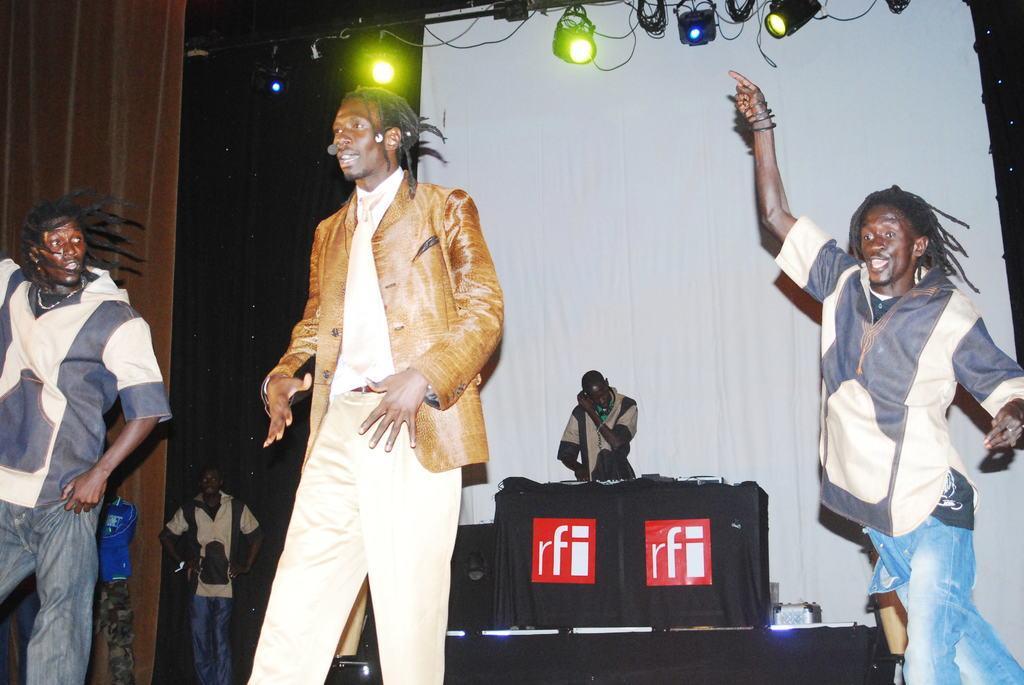How would you summarize this image in a sentence or two? In this image, we can see people and in the background, there is a table and we can see a cloth on it and some other objects and there are curtains, lights and some other objects. 